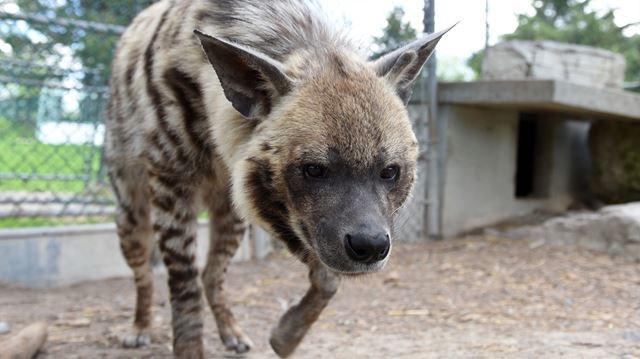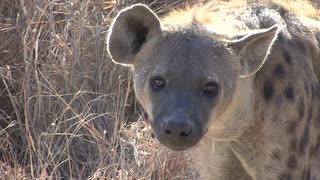The first image is the image on the left, the second image is the image on the right. Evaluate the accuracy of this statement regarding the images: "The hyena in the foreground of the left image is walking forward at a rightward angle with its head lowered and one front paw off the ground and bent inward.". Is it true? Answer yes or no. Yes. The first image is the image on the left, the second image is the image on the right. Evaluate the accuracy of this statement regarding the images: "There are two hyenas in the right image.". Is it true? Answer yes or no. No. 